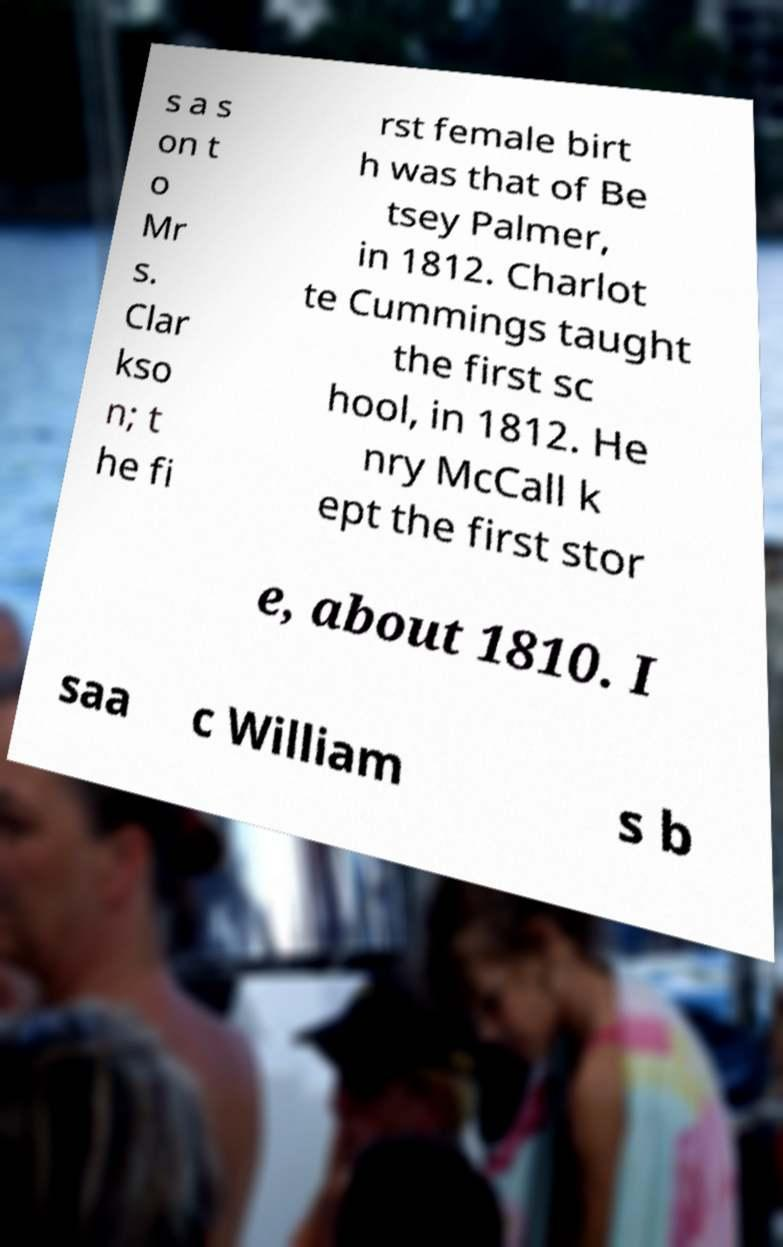There's text embedded in this image that I need extracted. Can you transcribe it verbatim? s a s on t o Mr s. Clar kso n; t he fi rst female birt h was that of Be tsey Palmer, in 1812. Charlot te Cummings taught the first sc hool, in 1812. He nry McCall k ept the first stor e, about 1810. I saa c William s b 